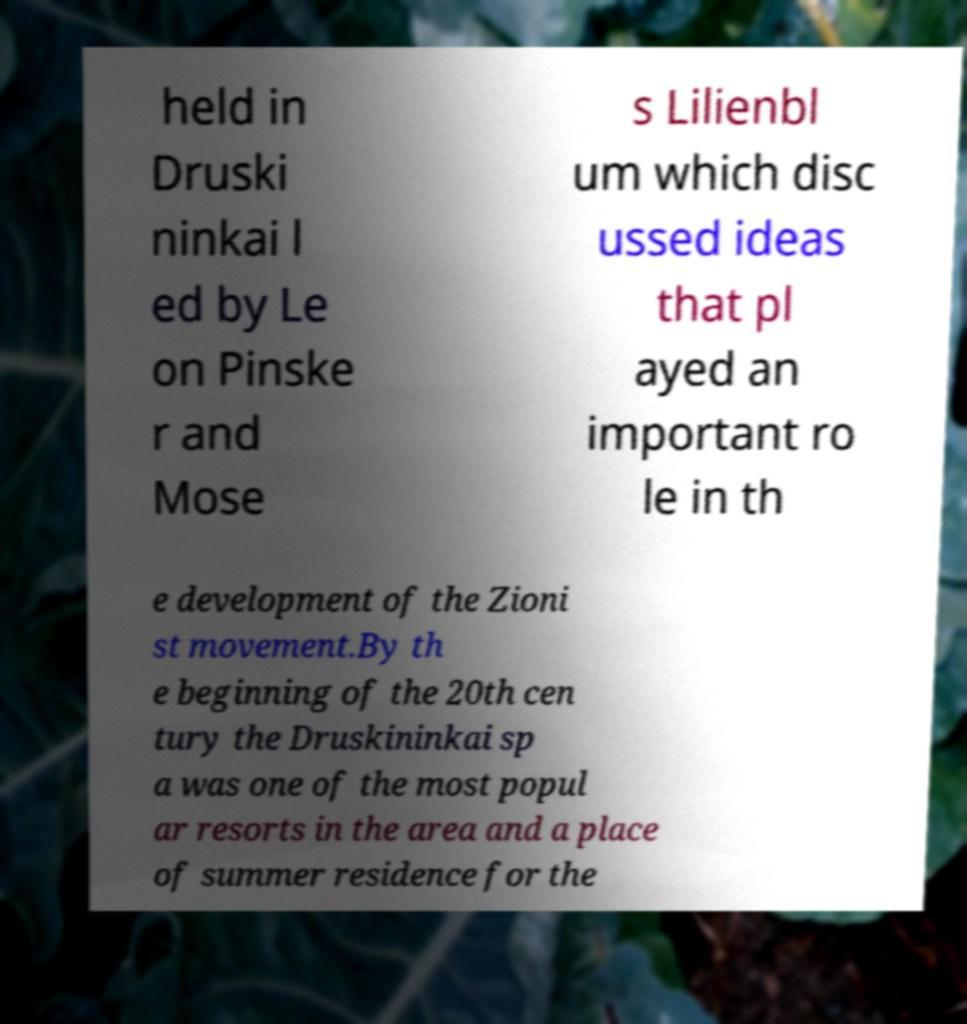What messages or text are displayed in this image? I need them in a readable, typed format. held in Druski ninkai l ed by Le on Pinske r and Mose s Lilienbl um which disc ussed ideas that pl ayed an important ro le in th e development of the Zioni st movement.By th e beginning of the 20th cen tury the Druskininkai sp a was one of the most popul ar resorts in the area and a place of summer residence for the 